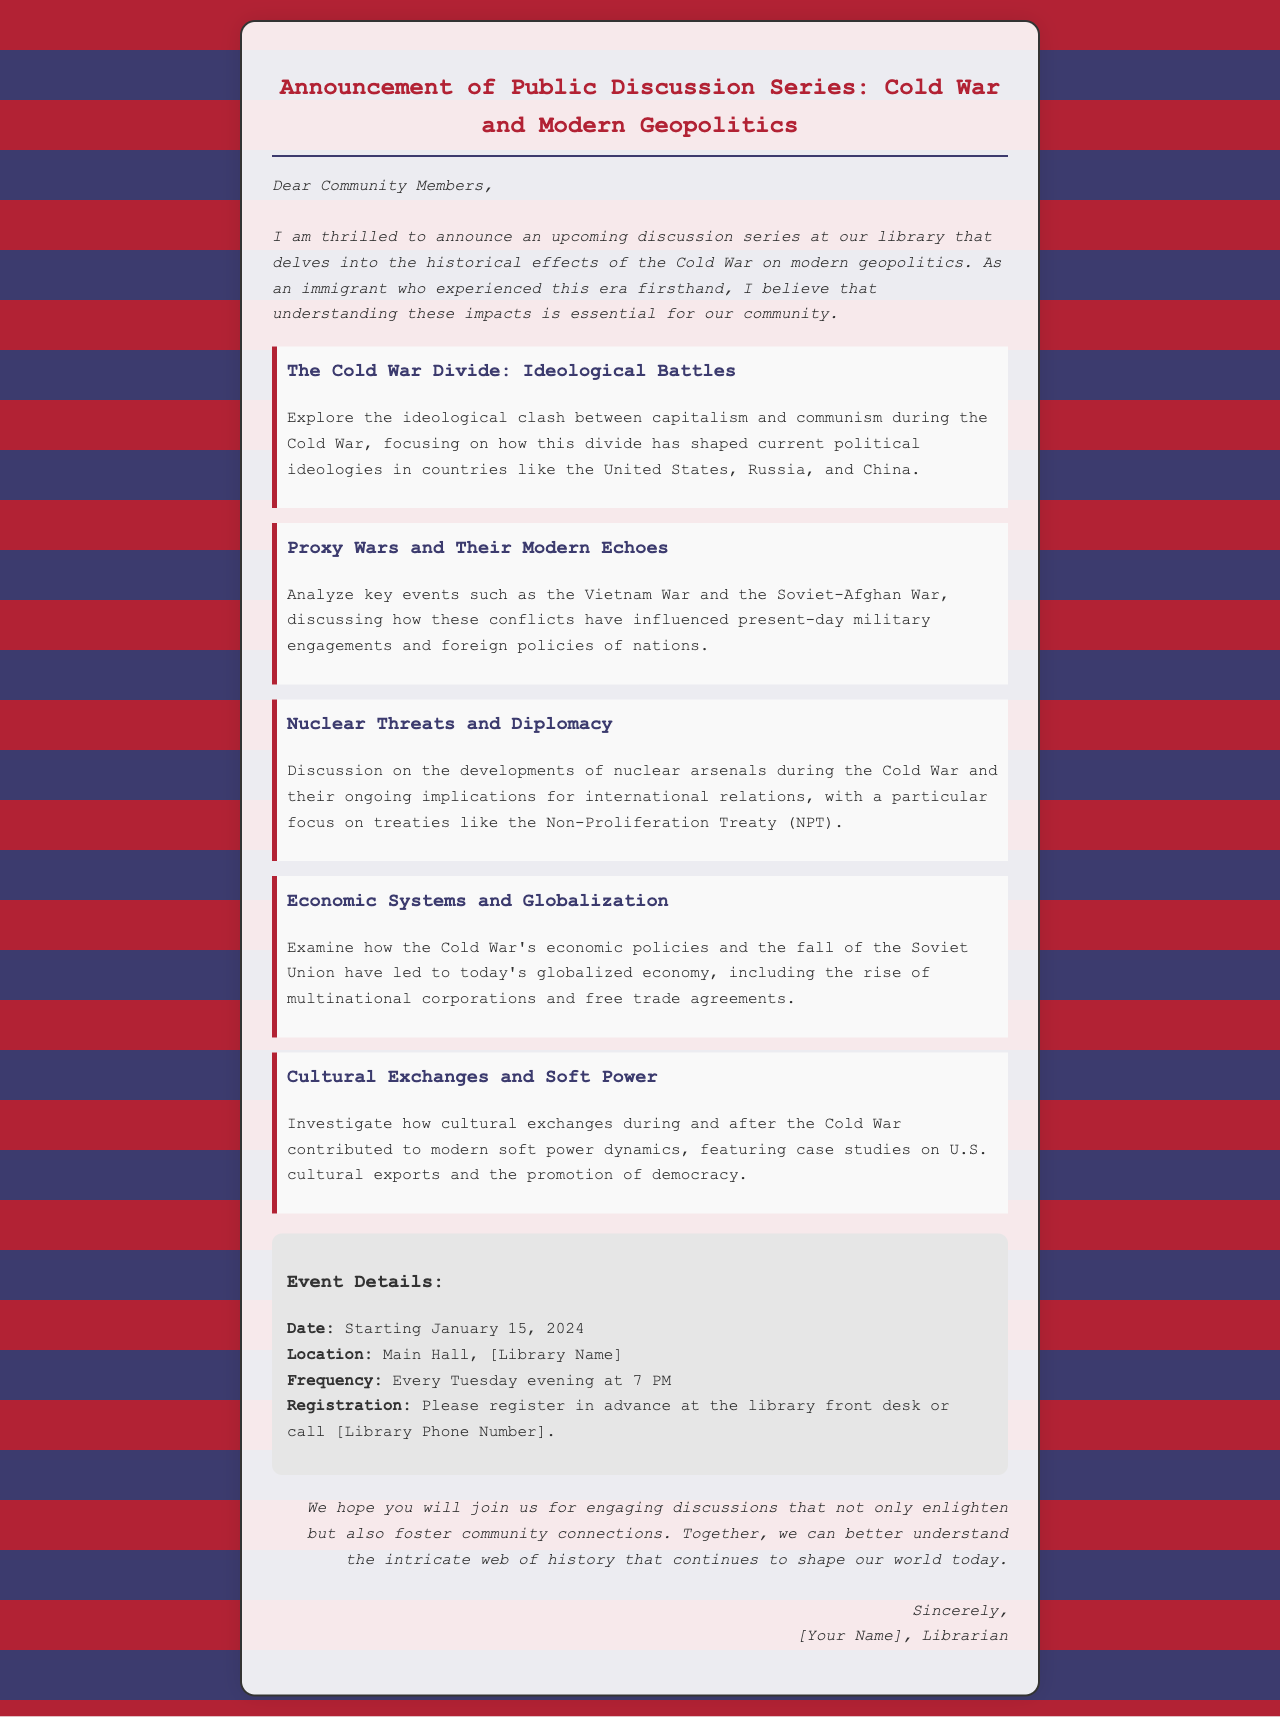What is the title of the discussion series? The title "Announcement of Public Discussion Series: Cold War and Modern Geopolitics" is found at the top of the document.
Answer: Cold War and Modern Geopolitics When does the discussion series start? The starting date of the series is mentioned in the event details section of the document.
Answer: January 15, 2024 Where will the discussions take place? The location is provided in the event details section, indicating where the discussions will be held.
Answer: Main Hall, [Library Name] How often will the discussions be held? The frequency of the meetings is specified in the event details, indicating how regularly the discussions will occur.
Answer: Every Tuesday What subject is explored in the topic "Proxy Wars and Their Modern Echoes"? This topic's content is described, indicating what specific historical events it focuses on.
Answer: Vietnam War and the Soviet-Afghan War What role does the author believe understanding the Cold War's impact plays in the community? The author expresses a belief about the importance of understanding historical impacts in the introductory paragraph.
Answer: Essential What type of event is being announced? The document clearly indicates the nature of the event being discussed in its title and throughout the text.
Answer: Discussion series What is required for participation in the event? The document specifies a requirement for participants regarding registration, indicating what they need to do to join.
Answer: Register in advance 